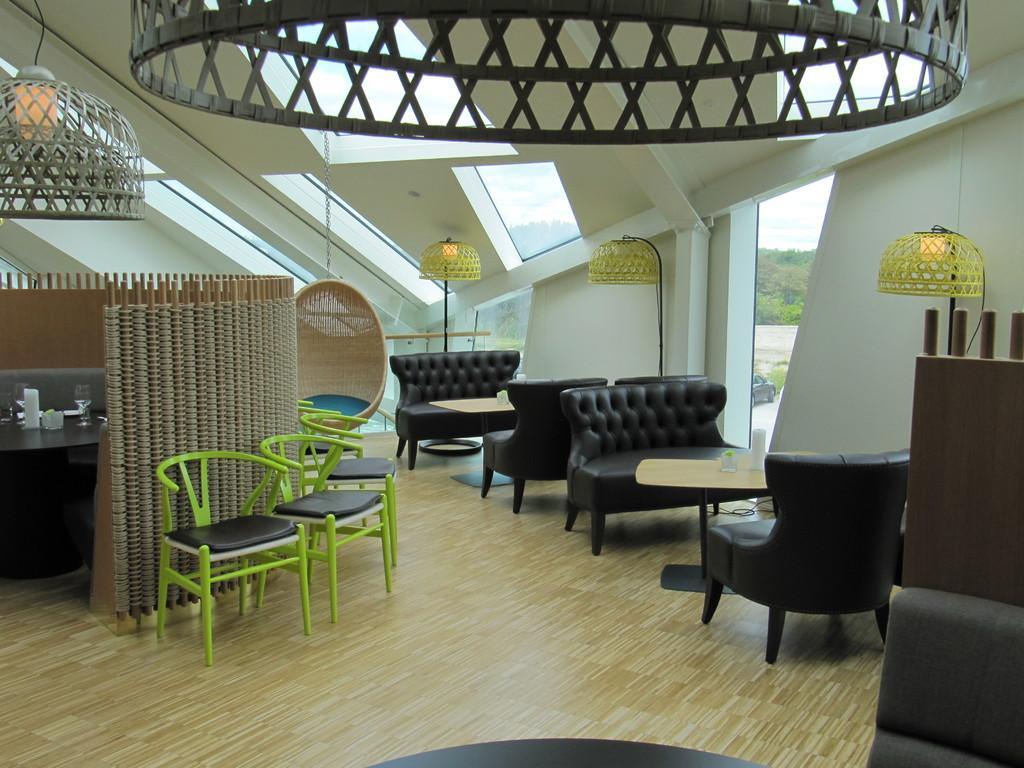Can you describe this image briefly? This picture is taken inside the room. In this image there are tables in the middle and there are sofas around the table. On the left side there are chairs on the wooden floor. At the top there are lights. On the right side there are lights beside the table. 